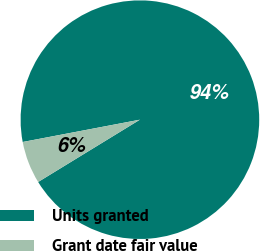Convert chart. <chart><loc_0><loc_0><loc_500><loc_500><pie_chart><fcel>Units granted<fcel>Grant date fair value<nl><fcel>94.25%<fcel>5.75%<nl></chart> 